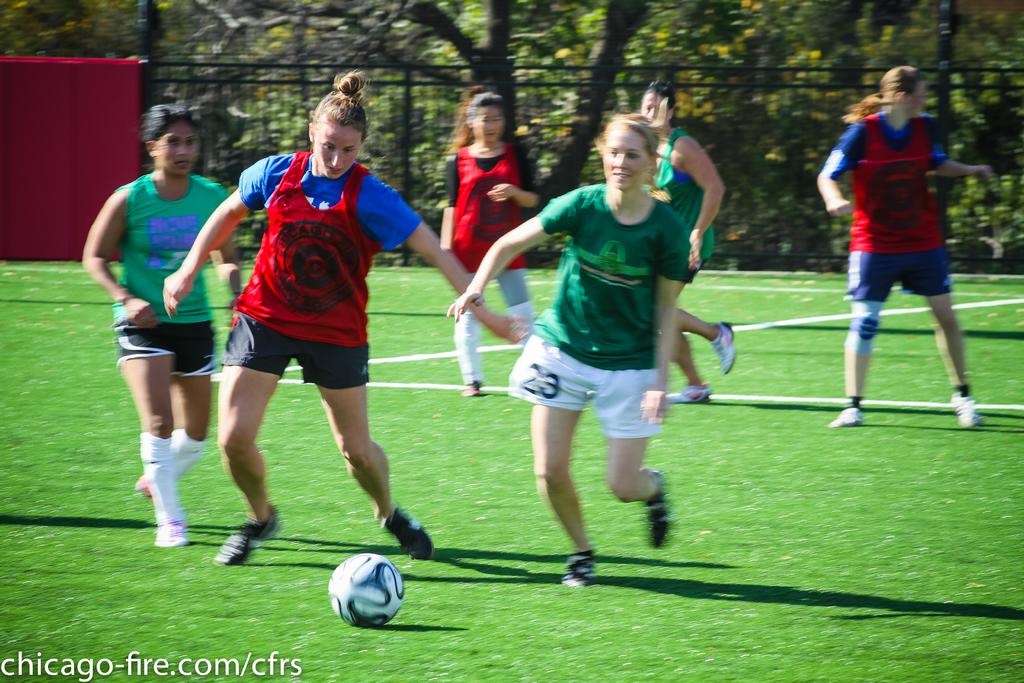Which website owns this image?
Keep it short and to the point. Chicago-fire.com/cfrs. 